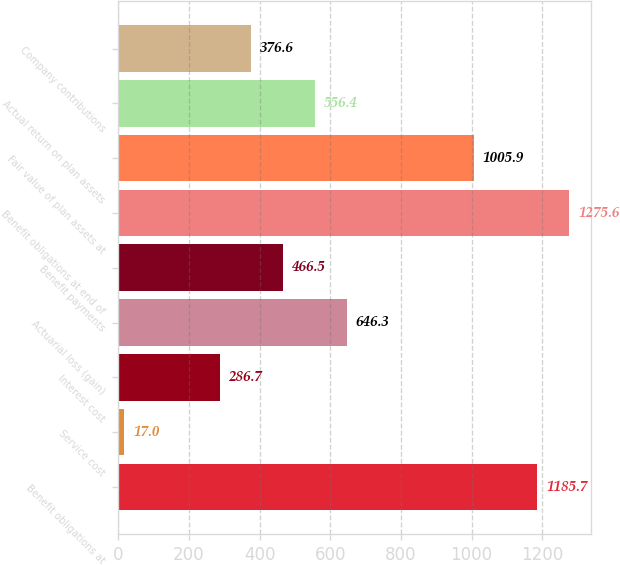Convert chart to OTSL. <chart><loc_0><loc_0><loc_500><loc_500><bar_chart><fcel>Benefit obligations at<fcel>Service cost<fcel>Interest cost<fcel>Actuarial loss (gain)<fcel>Benefit payments<fcel>Benefit obligations at end of<fcel>Fair value of plan assets at<fcel>Actual return on plan assets<fcel>Company contributions<nl><fcel>1185.7<fcel>17<fcel>286.7<fcel>646.3<fcel>466.5<fcel>1275.6<fcel>1005.9<fcel>556.4<fcel>376.6<nl></chart> 